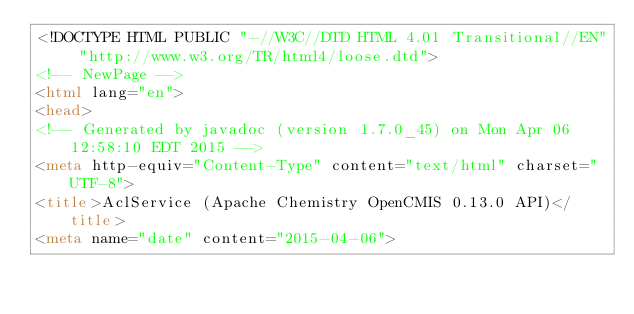<code> <loc_0><loc_0><loc_500><loc_500><_HTML_><!DOCTYPE HTML PUBLIC "-//W3C//DTD HTML 4.01 Transitional//EN" "http://www.w3.org/TR/html4/loose.dtd">
<!-- NewPage -->
<html lang="en">
<head>
<!-- Generated by javadoc (version 1.7.0_45) on Mon Apr 06 12:58:10 EDT 2015 -->
<meta http-equiv="Content-Type" content="text/html" charset="UTF-8">
<title>AclService (Apache Chemistry OpenCMIS 0.13.0 API)</title>
<meta name="date" content="2015-04-06"></code> 